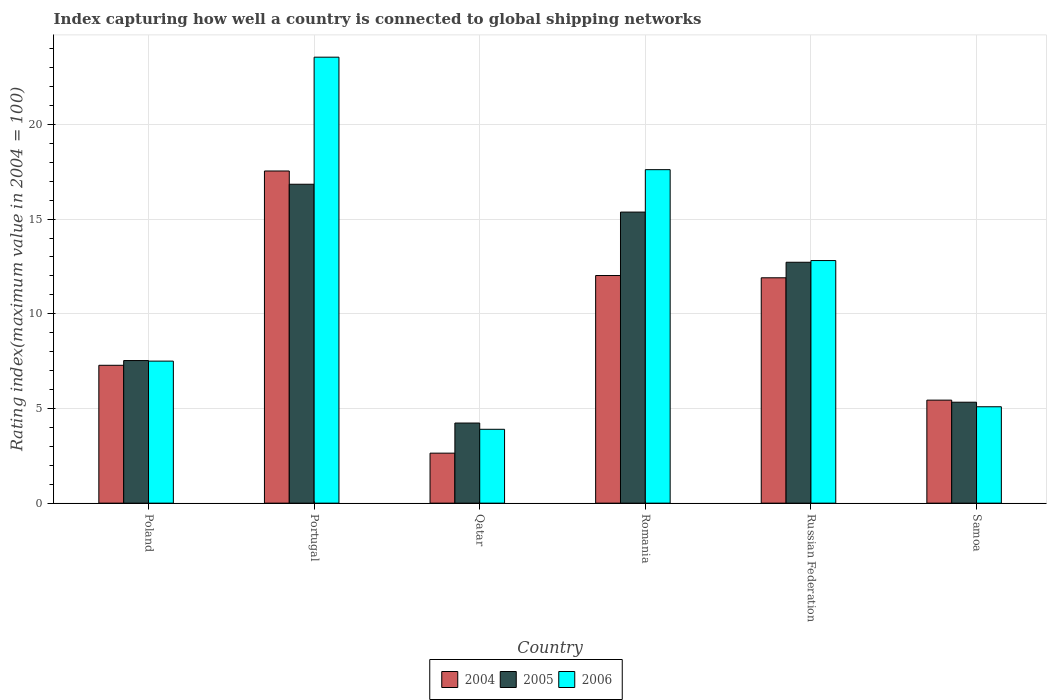How many different coloured bars are there?
Give a very brief answer. 3. Are the number of bars on each tick of the X-axis equal?
Make the answer very short. Yes. How many bars are there on the 1st tick from the left?
Offer a terse response. 3. How many bars are there on the 6th tick from the right?
Make the answer very short. 3. What is the label of the 5th group of bars from the left?
Ensure brevity in your answer.  Russian Federation. What is the rating index in 2005 in Poland?
Provide a short and direct response. 7.53. Across all countries, what is the maximum rating index in 2004?
Provide a short and direct response. 17.54. Across all countries, what is the minimum rating index in 2005?
Your answer should be compact. 4.23. In which country was the rating index in 2006 minimum?
Give a very brief answer. Qatar. What is the total rating index in 2006 in the graph?
Your answer should be compact. 70.46. What is the difference between the rating index in 2004 in Portugal and that in Russian Federation?
Make the answer very short. 5.64. What is the difference between the rating index in 2005 in Samoa and the rating index in 2004 in Qatar?
Make the answer very short. 2.69. What is the average rating index in 2006 per country?
Make the answer very short. 11.74. What is the difference between the rating index of/in 2006 and rating index of/in 2004 in Poland?
Your response must be concise. 0.22. What is the ratio of the rating index in 2005 in Qatar to that in Russian Federation?
Make the answer very short. 0.33. What is the difference between the highest and the second highest rating index in 2006?
Keep it short and to the point. 4.8. What is the difference between the highest and the lowest rating index in 2006?
Give a very brief answer. 19.65. In how many countries, is the rating index in 2004 greater than the average rating index in 2004 taken over all countries?
Make the answer very short. 3. Is the sum of the rating index in 2006 in Portugal and Qatar greater than the maximum rating index in 2004 across all countries?
Provide a short and direct response. Yes. What does the 1st bar from the left in Russian Federation represents?
Provide a succinct answer. 2004. Is it the case that in every country, the sum of the rating index in 2004 and rating index in 2005 is greater than the rating index in 2006?
Your answer should be very brief. Yes. Are all the bars in the graph horizontal?
Give a very brief answer. No. Where does the legend appear in the graph?
Give a very brief answer. Bottom center. What is the title of the graph?
Provide a short and direct response. Index capturing how well a country is connected to global shipping networks. Does "1975" appear as one of the legend labels in the graph?
Ensure brevity in your answer.  No. What is the label or title of the X-axis?
Give a very brief answer. Country. What is the label or title of the Y-axis?
Provide a succinct answer. Rating index(maximum value in 2004 = 100). What is the Rating index(maximum value in 2004 = 100) of 2004 in Poland?
Your answer should be compact. 7.28. What is the Rating index(maximum value in 2004 = 100) of 2005 in Poland?
Keep it short and to the point. 7.53. What is the Rating index(maximum value in 2004 = 100) in 2006 in Poland?
Ensure brevity in your answer.  7.5. What is the Rating index(maximum value in 2004 = 100) of 2004 in Portugal?
Give a very brief answer. 17.54. What is the Rating index(maximum value in 2004 = 100) in 2005 in Portugal?
Keep it short and to the point. 16.84. What is the Rating index(maximum value in 2004 = 100) of 2006 in Portugal?
Your response must be concise. 23.55. What is the Rating index(maximum value in 2004 = 100) of 2004 in Qatar?
Offer a terse response. 2.64. What is the Rating index(maximum value in 2004 = 100) in 2005 in Qatar?
Keep it short and to the point. 4.23. What is the Rating index(maximum value in 2004 = 100) of 2006 in Qatar?
Keep it short and to the point. 3.9. What is the Rating index(maximum value in 2004 = 100) in 2004 in Romania?
Your answer should be compact. 12.02. What is the Rating index(maximum value in 2004 = 100) in 2005 in Romania?
Offer a terse response. 15.37. What is the Rating index(maximum value in 2004 = 100) in 2006 in Romania?
Give a very brief answer. 17.61. What is the Rating index(maximum value in 2004 = 100) of 2005 in Russian Federation?
Offer a terse response. 12.72. What is the Rating index(maximum value in 2004 = 100) of 2006 in Russian Federation?
Ensure brevity in your answer.  12.81. What is the Rating index(maximum value in 2004 = 100) in 2004 in Samoa?
Make the answer very short. 5.44. What is the Rating index(maximum value in 2004 = 100) in 2005 in Samoa?
Keep it short and to the point. 5.33. What is the Rating index(maximum value in 2004 = 100) in 2006 in Samoa?
Provide a succinct answer. 5.09. Across all countries, what is the maximum Rating index(maximum value in 2004 = 100) in 2004?
Ensure brevity in your answer.  17.54. Across all countries, what is the maximum Rating index(maximum value in 2004 = 100) in 2005?
Ensure brevity in your answer.  16.84. Across all countries, what is the maximum Rating index(maximum value in 2004 = 100) in 2006?
Your answer should be compact. 23.55. Across all countries, what is the minimum Rating index(maximum value in 2004 = 100) in 2004?
Give a very brief answer. 2.64. Across all countries, what is the minimum Rating index(maximum value in 2004 = 100) in 2005?
Your answer should be compact. 4.23. Across all countries, what is the minimum Rating index(maximum value in 2004 = 100) in 2006?
Your answer should be very brief. 3.9. What is the total Rating index(maximum value in 2004 = 100) in 2004 in the graph?
Offer a terse response. 56.82. What is the total Rating index(maximum value in 2004 = 100) of 2005 in the graph?
Your response must be concise. 62.02. What is the total Rating index(maximum value in 2004 = 100) of 2006 in the graph?
Ensure brevity in your answer.  70.46. What is the difference between the Rating index(maximum value in 2004 = 100) in 2004 in Poland and that in Portugal?
Offer a terse response. -10.26. What is the difference between the Rating index(maximum value in 2004 = 100) of 2005 in Poland and that in Portugal?
Your answer should be very brief. -9.31. What is the difference between the Rating index(maximum value in 2004 = 100) in 2006 in Poland and that in Portugal?
Provide a short and direct response. -16.05. What is the difference between the Rating index(maximum value in 2004 = 100) of 2004 in Poland and that in Qatar?
Keep it short and to the point. 4.64. What is the difference between the Rating index(maximum value in 2004 = 100) in 2006 in Poland and that in Qatar?
Your answer should be compact. 3.6. What is the difference between the Rating index(maximum value in 2004 = 100) in 2004 in Poland and that in Romania?
Offer a very short reply. -4.74. What is the difference between the Rating index(maximum value in 2004 = 100) of 2005 in Poland and that in Romania?
Ensure brevity in your answer.  -7.84. What is the difference between the Rating index(maximum value in 2004 = 100) of 2006 in Poland and that in Romania?
Your response must be concise. -10.11. What is the difference between the Rating index(maximum value in 2004 = 100) of 2004 in Poland and that in Russian Federation?
Make the answer very short. -4.62. What is the difference between the Rating index(maximum value in 2004 = 100) in 2005 in Poland and that in Russian Federation?
Provide a short and direct response. -5.19. What is the difference between the Rating index(maximum value in 2004 = 100) of 2006 in Poland and that in Russian Federation?
Keep it short and to the point. -5.31. What is the difference between the Rating index(maximum value in 2004 = 100) of 2004 in Poland and that in Samoa?
Your answer should be very brief. 1.84. What is the difference between the Rating index(maximum value in 2004 = 100) in 2006 in Poland and that in Samoa?
Keep it short and to the point. 2.41. What is the difference between the Rating index(maximum value in 2004 = 100) in 2004 in Portugal and that in Qatar?
Your answer should be very brief. 14.9. What is the difference between the Rating index(maximum value in 2004 = 100) of 2005 in Portugal and that in Qatar?
Ensure brevity in your answer.  12.61. What is the difference between the Rating index(maximum value in 2004 = 100) in 2006 in Portugal and that in Qatar?
Make the answer very short. 19.65. What is the difference between the Rating index(maximum value in 2004 = 100) in 2004 in Portugal and that in Romania?
Provide a short and direct response. 5.52. What is the difference between the Rating index(maximum value in 2004 = 100) in 2005 in Portugal and that in Romania?
Your answer should be compact. 1.47. What is the difference between the Rating index(maximum value in 2004 = 100) of 2006 in Portugal and that in Romania?
Provide a short and direct response. 5.94. What is the difference between the Rating index(maximum value in 2004 = 100) in 2004 in Portugal and that in Russian Federation?
Keep it short and to the point. 5.64. What is the difference between the Rating index(maximum value in 2004 = 100) of 2005 in Portugal and that in Russian Federation?
Your answer should be very brief. 4.12. What is the difference between the Rating index(maximum value in 2004 = 100) in 2006 in Portugal and that in Russian Federation?
Provide a short and direct response. 10.74. What is the difference between the Rating index(maximum value in 2004 = 100) in 2004 in Portugal and that in Samoa?
Ensure brevity in your answer.  12.1. What is the difference between the Rating index(maximum value in 2004 = 100) in 2005 in Portugal and that in Samoa?
Your answer should be very brief. 11.51. What is the difference between the Rating index(maximum value in 2004 = 100) in 2006 in Portugal and that in Samoa?
Give a very brief answer. 18.46. What is the difference between the Rating index(maximum value in 2004 = 100) in 2004 in Qatar and that in Romania?
Ensure brevity in your answer.  -9.38. What is the difference between the Rating index(maximum value in 2004 = 100) of 2005 in Qatar and that in Romania?
Provide a short and direct response. -11.14. What is the difference between the Rating index(maximum value in 2004 = 100) of 2006 in Qatar and that in Romania?
Ensure brevity in your answer.  -13.71. What is the difference between the Rating index(maximum value in 2004 = 100) of 2004 in Qatar and that in Russian Federation?
Provide a succinct answer. -9.26. What is the difference between the Rating index(maximum value in 2004 = 100) in 2005 in Qatar and that in Russian Federation?
Provide a short and direct response. -8.49. What is the difference between the Rating index(maximum value in 2004 = 100) of 2006 in Qatar and that in Russian Federation?
Your answer should be very brief. -8.91. What is the difference between the Rating index(maximum value in 2004 = 100) in 2004 in Qatar and that in Samoa?
Make the answer very short. -2.8. What is the difference between the Rating index(maximum value in 2004 = 100) of 2005 in Qatar and that in Samoa?
Keep it short and to the point. -1.1. What is the difference between the Rating index(maximum value in 2004 = 100) in 2006 in Qatar and that in Samoa?
Provide a short and direct response. -1.19. What is the difference between the Rating index(maximum value in 2004 = 100) of 2004 in Romania and that in Russian Federation?
Offer a terse response. 0.12. What is the difference between the Rating index(maximum value in 2004 = 100) of 2005 in Romania and that in Russian Federation?
Provide a succinct answer. 2.65. What is the difference between the Rating index(maximum value in 2004 = 100) in 2004 in Romania and that in Samoa?
Make the answer very short. 6.58. What is the difference between the Rating index(maximum value in 2004 = 100) in 2005 in Romania and that in Samoa?
Offer a very short reply. 10.04. What is the difference between the Rating index(maximum value in 2004 = 100) of 2006 in Romania and that in Samoa?
Make the answer very short. 12.52. What is the difference between the Rating index(maximum value in 2004 = 100) of 2004 in Russian Federation and that in Samoa?
Offer a terse response. 6.46. What is the difference between the Rating index(maximum value in 2004 = 100) in 2005 in Russian Federation and that in Samoa?
Offer a terse response. 7.39. What is the difference between the Rating index(maximum value in 2004 = 100) in 2006 in Russian Federation and that in Samoa?
Make the answer very short. 7.72. What is the difference between the Rating index(maximum value in 2004 = 100) in 2004 in Poland and the Rating index(maximum value in 2004 = 100) in 2005 in Portugal?
Make the answer very short. -9.56. What is the difference between the Rating index(maximum value in 2004 = 100) of 2004 in Poland and the Rating index(maximum value in 2004 = 100) of 2006 in Portugal?
Your response must be concise. -16.27. What is the difference between the Rating index(maximum value in 2004 = 100) of 2005 in Poland and the Rating index(maximum value in 2004 = 100) of 2006 in Portugal?
Your response must be concise. -16.02. What is the difference between the Rating index(maximum value in 2004 = 100) in 2004 in Poland and the Rating index(maximum value in 2004 = 100) in 2005 in Qatar?
Make the answer very short. 3.05. What is the difference between the Rating index(maximum value in 2004 = 100) of 2004 in Poland and the Rating index(maximum value in 2004 = 100) of 2006 in Qatar?
Your answer should be compact. 3.38. What is the difference between the Rating index(maximum value in 2004 = 100) in 2005 in Poland and the Rating index(maximum value in 2004 = 100) in 2006 in Qatar?
Your response must be concise. 3.63. What is the difference between the Rating index(maximum value in 2004 = 100) of 2004 in Poland and the Rating index(maximum value in 2004 = 100) of 2005 in Romania?
Offer a terse response. -8.09. What is the difference between the Rating index(maximum value in 2004 = 100) of 2004 in Poland and the Rating index(maximum value in 2004 = 100) of 2006 in Romania?
Your answer should be very brief. -10.33. What is the difference between the Rating index(maximum value in 2004 = 100) in 2005 in Poland and the Rating index(maximum value in 2004 = 100) in 2006 in Romania?
Your response must be concise. -10.08. What is the difference between the Rating index(maximum value in 2004 = 100) of 2004 in Poland and the Rating index(maximum value in 2004 = 100) of 2005 in Russian Federation?
Your answer should be very brief. -5.44. What is the difference between the Rating index(maximum value in 2004 = 100) in 2004 in Poland and the Rating index(maximum value in 2004 = 100) in 2006 in Russian Federation?
Ensure brevity in your answer.  -5.53. What is the difference between the Rating index(maximum value in 2004 = 100) in 2005 in Poland and the Rating index(maximum value in 2004 = 100) in 2006 in Russian Federation?
Offer a very short reply. -5.28. What is the difference between the Rating index(maximum value in 2004 = 100) of 2004 in Poland and the Rating index(maximum value in 2004 = 100) of 2005 in Samoa?
Give a very brief answer. 1.95. What is the difference between the Rating index(maximum value in 2004 = 100) in 2004 in Poland and the Rating index(maximum value in 2004 = 100) in 2006 in Samoa?
Ensure brevity in your answer.  2.19. What is the difference between the Rating index(maximum value in 2004 = 100) of 2005 in Poland and the Rating index(maximum value in 2004 = 100) of 2006 in Samoa?
Your response must be concise. 2.44. What is the difference between the Rating index(maximum value in 2004 = 100) in 2004 in Portugal and the Rating index(maximum value in 2004 = 100) in 2005 in Qatar?
Provide a succinct answer. 13.31. What is the difference between the Rating index(maximum value in 2004 = 100) of 2004 in Portugal and the Rating index(maximum value in 2004 = 100) of 2006 in Qatar?
Your answer should be very brief. 13.64. What is the difference between the Rating index(maximum value in 2004 = 100) in 2005 in Portugal and the Rating index(maximum value in 2004 = 100) in 2006 in Qatar?
Provide a succinct answer. 12.94. What is the difference between the Rating index(maximum value in 2004 = 100) in 2004 in Portugal and the Rating index(maximum value in 2004 = 100) in 2005 in Romania?
Ensure brevity in your answer.  2.17. What is the difference between the Rating index(maximum value in 2004 = 100) of 2004 in Portugal and the Rating index(maximum value in 2004 = 100) of 2006 in Romania?
Your answer should be compact. -0.07. What is the difference between the Rating index(maximum value in 2004 = 100) of 2005 in Portugal and the Rating index(maximum value in 2004 = 100) of 2006 in Romania?
Your response must be concise. -0.77. What is the difference between the Rating index(maximum value in 2004 = 100) of 2004 in Portugal and the Rating index(maximum value in 2004 = 100) of 2005 in Russian Federation?
Ensure brevity in your answer.  4.82. What is the difference between the Rating index(maximum value in 2004 = 100) in 2004 in Portugal and the Rating index(maximum value in 2004 = 100) in 2006 in Russian Federation?
Ensure brevity in your answer.  4.73. What is the difference between the Rating index(maximum value in 2004 = 100) in 2005 in Portugal and the Rating index(maximum value in 2004 = 100) in 2006 in Russian Federation?
Offer a terse response. 4.03. What is the difference between the Rating index(maximum value in 2004 = 100) in 2004 in Portugal and the Rating index(maximum value in 2004 = 100) in 2005 in Samoa?
Give a very brief answer. 12.21. What is the difference between the Rating index(maximum value in 2004 = 100) of 2004 in Portugal and the Rating index(maximum value in 2004 = 100) of 2006 in Samoa?
Your answer should be very brief. 12.45. What is the difference between the Rating index(maximum value in 2004 = 100) of 2005 in Portugal and the Rating index(maximum value in 2004 = 100) of 2006 in Samoa?
Provide a succinct answer. 11.75. What is the difference between the Rating index(maximum value in 2004 = 100) of 2004 in Qatar and the Rating index(maximum value in 2004 = 100) of 2005 in Romania?
Ensure brevity in your answer.  -12.73. What is the difference between the Rating index(maximum value in 2004 = 100) of 2004 in Qatar and the Rating index(maximum value in 2004 = 100) of 2006 in Romania?
Make the answer very short. -14.97. What is the difference between the Rating index(maximum value in 2004 = 100) of 2005 in Qatar and the Rating index(maximum value in 2004 = 100) of 2006 in Romania?
Ensure brevity in your answer.  -13.38. What is the difference between the Rating index(maximum value in 2004 = 100) of 2004 in Qatar and the Rating index(maximum value in 2004 = 100) of 2005 in Russian Federation?
Your answer should be very brief. -10.08. What is the difference between the Rating index(maximum value in 2004 = 100) in 2004 in Qatar and the Rating index(maximum value in 2004 = 100) in 2006 in Russian Federation?
Ensure brevity in your answer.  -10.17. What is the difference between the Rating index(maximum value in 2004 = 100) in 2005 in Qatar and the Rating index(maximum value in 2004 = 100) in 2006 in Russian Federation?
Offer a terse response. -8.58. What is the difference between the Rating index(maximum value in 2004 = 100) of 2004 in Qatar and the Rating index(maximum value in 2004 = 100) of 2005 in Samoa?
Keep it short and to the point. -2.69. What is the difference between the Rating index(maximum value in 2004 = 100) of 2004 in Qatar and the Rating index(maximum value in 2004 = 100) of 2006 in Samoa?
Offer a very short reply. -2.45. What is the difference between the Rating index(maximum value in 2004 = 100) in 2005 in Qatar and the Rating index(maximum value in 2004 = 100) in 2006 in Samoa?
Your answer should be very brief. -0.86. What is the difference between the Rating index(maximum value in 2004 = 100) in 2004 in Romania and the Rating index(maximum value in 2004 = 100) in 2005 in Russian Federation?
Your response must be concise. -0.7. What is the difference between the Rating index(maximum value in 2004 = 100) of 2004 in Romania and the Rating index(maximum value in 2004 = 100) of 2006 in Russian Federation?
Ensure brevity in your answer.  -0.79. What is the difference between the Rating index(maximum value in 2004 = 100) in 2005 in Romania and the Rating index(maximum value in 2004 = 100) in 2006 in Russian Federation?
Your answer should be compact. 2.56. What is the difference between the Rating index(maximum value in 2004 = 100) of 2004 in Romania and the Rating index(maximum value in 2004 = 100) of 2005 in Samoa?
Keep it short and to the point. 6.69. What is the difference between the Rating index(maximum value in 2004 = 100) in 2004 in Romania and the Rating index(maximum value in 2004 = 100) in 2006 in Samoa?
Provide a short and direct response. 6.93. What is the difference between the Rating index(maximum value in 2004 = 100) in 2005 in Romania and the Rating index(maximum value in 2004 = 100) in 2006 in Samoa?
Provide a short and direct response. 10.28. What is the difference between the Rating index(maximum value in 2004 = 100) of 2004 in Russian Federation and the Rating index(maximum value in 2004 = 100) of 2005 in Samoa?
Give a very brief answer. 6.57. What is the difference between the Rating index(maximum value in 2004 = 100) in 2004 in Russian Federation and the Rating index(maximum value in 2004 = 100) in 2006 in Samoa?
Offer a very short reply. 6.81. What is the difference between the Rating index(maximum value in 2004 = 100) of 2005 in Russian Federation and the Rating index(maximum value in 2004 = 100) of 2006 in Samoa?
Your answer should be compact. 7.63. What is the average Rating index(maximum value in 2004 = 100) in 2004 per country?
Provide a short and direct response. 9.47. What is the average Rating index(maximum value in 2004 = 100) in 2005 per country?
Offer a terse response. 10.34. What is the average Rating index(maximum value in 2004 = 100) in 2006 per country?
Offer a very short reply. 11.74. What is the difference between the Rating index(maximum value in 2004 = 100) of 2004 and Rating index(maximum value in 2004 = 100) of 2006 in Poland?
Offer a terse response. -0.22. What is the difference between the Rating index(maximum value in 2004 = 100) of 2005 and Rating index(maximum value in 2004 = 100) of 2006 in Poland?
Provide a succinct answer. 0.03. What is the difference between the Rating index(maximum value in 2004 = 100) in 2004 and Rating index(maximum value in 2004 = 100) in 2006 in Portugal?
Provide a short and direct response. -6.01. What is the difference between the Rating index(maximum value in 2004 = 100) of 2005 and Rating index(maximum value in 2004 = 100) of 2006 in Portugal?
Your answer should be compact. -6.71. What is the difference between the Rating index(maximum value in 2004 = 100) in 2004 and Rating index(maximum value in 2004 = 100) in 2005 in Qatar?
Your answer should be compact. -1.59. What is the difference between the Rating index(maximum value in 2004 = 100) in 2004 and Rating index(maximum value in 2004 = 100) in 2006 in Qatar?
Make the answer very short. -1.26. What is the difference between the Rating index(maximum value in 2004 = 100) of 2005 and Rating index(maximum value in 2004 = 100) of 2006 in Qatar?
Keep it short and to the point. 0.33. What is the difference between the Rating index(maximum value in 2004 = 100) in 2004 and Rating index(maximum value in 2004 = 100) in 2005 in Romania?
Offer a terse response. -3.35. What is the difference between the Rating index(maximum value in 2004 = 100) of 2004 and Rating index(maximum value in 2004 = 100) of 2006 in Romania?
Provide a succinct answer. -5.59. What is the difference between the Rating index(maximum value in 2004 = 100) in 2005 and Rating index(maximum value in 2004 = 100) in 2006 in Romania?
Provide a succinct answer. -2.24. What is the difference between the Rating index(maximum value in 2004 = 100) in 2004 and Rating index(maximum value in 2004 = 100) in 2005 in Russian Federation?
Offer a terse response. -0.82. What is the difference between the Rating index(maximum value in 2004 = 100) of 2004 and Rating index(maximum value in 2004 = 100) of 2006 in Russian Federation?
Provide a succinct answer. -0.91. What is the difference between the Rating index(maximum value in 2004 = 100) of 2005 and Rating index(maximum value in 2004 = 100) of 2006 in Russian Federation?
Offer a very short reply. -0.09. What is the difference between the Rating index(maximum value in 2004 = 100) of 2004 and Rating index(maximum value in 2004 = 100) of 2005 in Samoa?
Offer a terse response. 0.11. What is the difference between the Rating index(maximum value in 2004 = 100) of 2004 and Rating index(maximum value in 2004 = 100) of 2006 in Samoa?
Provide a succinct answer. 0.35. What is the difference between the Rating index(maximum value in 2004 = 100) of 2005 and Rating index(maximum value in 2004 = 100) of 2006 in Samoa?
Your response must be concise. 0.24. What is the ratio of the Rating index(maximum value in 2004 = 100) of 2004 in Poland to that in Portugal?
Provide a short and direct response. 0.42. What is the ratio of the Rating index(maximum value in 2004 = 100) in 2005 in Poland to that in Portugal?
Offer a very short reply. 0.45. What is the ratio of the Rating index(maximum value in 2004 = 100) of 2006 in Poland to that in Portugal?
Provide a short and direct response. 0.32. What is the ratio of the Rating index(maximum value in 2004 = 100) in 2004 in Poland to that in Qatar?
Your answer should be compact. 2.76. What is the ratio of the Rating index(maximum value in 2004 = 100) of 2005 in Poland to that in Qatar?
Offer a very short reply. 1.78. What is the ratio of the Rating index(maximum value in 2004 = 100) in 2006 in Poland to that in Qatar?
Provide a short and direct response. 1.92. What is the ratio of the Rating index(maximum value in 2004 = 100) of 2004 in Poland to that in Romania?
Your answer should be very brief. 0.61. What is the ratio of the Rating index(maximum value in 2004 = 100) of 2005 in Poland to that in Romania?
Offer a terse response. 0.49. What is the ratio of the Rating index(maximum value in 2004 = 100) in 2006 in Poland to that in Romania?
Offer a terse response. 0.43. What is the ratio of the Rating index(maximum value in 2004 = 100) in 2004 in Poland to that in Russian Federation?
Keep it short and to the point. 0.61. What is the ratio of the Rating index(maximum value in 2004 = 100) in 2005 in Poland to that in Russian Federation?
Provide a short and direct response. 0.59. What is the ratio of the Rating index(maximum value in 2004 = 100) of 2006 in Poland to that in Russian Federation?
Ensure brevity in your answer.  0.59. What is the ratio of the Rating index(maximum value in 2004 = 100) in 2004 in Poland to that in Samoa?
Keep it short and to the point. 1.34. What is the ratio of the Rating index(maximum value in 2004 = 100) in 2005 in Poland to that in Samoa?
Provide a short and direct response. 1.41. What is the ratio of the Rating index(maximum value in 2004 = 100) of 2006 in Poland to that in Samoa?
Provide a succinct answer. 1.47. What is the ratio of the Rating index(maximum value in 2004 = 100) of 2004 in Portugal to that in Qatar?
Ensure brevity in your answer.  6.64. What is the ratio of the Rating index(maximum value in 2004 = 100) in 2005 in Portugal to that in Qatar?
Offer a very short reply. 3.98. What is the ratio of the Rating index(maximum value in 2004 = 100) in 2006 in Portugal to that in Qatar?
Ensure brevity in your answer.  6.04. What is the ratio of the Rating index(maximum value in 2004 = 100) of 2004 in Portugal to that in Romania?
Give a very brief answer. 1.46. What is the ratio of the Rating index(maximum value in 2004 = 100) of 2005 in Portugal to that in Romania?
Your answer should be compact. 1.1. What is the ratio of the Rating index(maximum value in 2004 = 100) of 2006 in Portugal to that in Romania?
Your response must be concise. 1.34. What is the ratio of the Rating index(maximum value in 2004 = 100) of 2004 in Portugal to that in Russian Federation?
Provide a short and direct response. 1.47. What is the ratio of the Rating index(maximum value in 2004 = 100) of 2005 in Portugal to that in Russian Federation?
Make the answer very short. 1.32. What is the ratio of the Rating index(maximum value in 2004 = 100) of 2006 in Portugal to that in Russian Federation?
Your answer should be compact. 1.84. What is the ratio of the Rating index(maximum value in 2004 = 100) of 2004 in Portugal to that in Samoa?
Make the answer very short. 3.22. What is the ratio of the Rating index(maximum value in 2004 = 100) in 2005 in Portugal to that in Samoa?
Provide a short and direct response. 3.16. What is the ratio of the Rating index(maximum value in 2004 = 100) of 2006 in Portugal to that in Samoa?
Your response must be concise. 4.63. What is the ratio of the Rating index(maximum value in 2004 = 100) in 2004 in Qatar to that in Romania?
Offer a terse response. 0.22. What is the ratio of the Rating index(maximum value in 2004 = 100) of 2005 in Qatar to that in Romania?
Your response must be concise. 0.28. What is the ratio of the Rating index(maximum value in 2004 = 100) in 2006 in Qatar to that in Romania?
Your answer should be very brief. 0.22. What is the ratio of the Rating index(maximum value in 2004 = 100) in 2004 in Qatar to that in Russian Federation?
Your response must be concise. 0.22. What is the ratio of the Rating index(maximum value in 2004 = 100) of 2005 in Qatar to that in Russian Federation?
Ensure brevity in your answer.  0.33. What is the ratio of the Rating index(maximum value in 2004 = 100) of 2006 in Qatar to that in Russian Federation?
Offer a terse response. 0.3. What is the ratio of the Rating index(maximum value in 2004 = 100) in 2004 in Qatar to that in Samoa?
Your answer should be very brief. 0.49. What is the ratio of the Rating index(maximum value in 2004 = 100) in 2005 in Qatar to that in Samoa?
Provide a succinct answer. 0.79. What is the ratio of the Rating index(maximum value in 2004 = 100) of 2006 in Qatar to that in Samoa?
Offer a very short reply. 0.77. What is the ratio of the Rating index(maximum value in 2004 = 100) in 2004 in Romania to that in Russian Federation?
Your answer should be compact. 1.01. What is the ratio of the Rating index(maximum value in 2004 = 100) of 2005 in Romania to that in Russian Federation?
Your answer should be very brief. 1.21. What is the ratio of the Rating index(maximum value in 2004 = 100) of 2006 in Romania to that in Russian Federation?
Keep it short and to the point. 1.37. What is the ratio of the Rating index(maximum value in 2004 = 100) in 2004 in Romania to that in Samoa?
Your answer should be compact. 2.21. What is the ratio of the Rating index(maximum value in 2004 = 100) of 2005 in Romania to that in Samoa?
Provide a short and direct response. 2.88. What is the ratio of the Rating index(maximum value in 2004 = 100) of 2006 in Romania to that in Samoa?
Ensure brevity in your answer.  3.46. What is the ratio of the Rating index(maximum value in 2004 = 100) of 2004 in Russian Federation to that in Samoa?
Your answer should be compact. 2.19. What is the ratio of the Rating index(maximum value in 2004 = 100) in 2005 in Russian Federation to that in Samoa?
Offer a terse response. 2.39. What is the ratio of the Rating index(maximum value in 2004 = 100) of 2006 in Russian Federation to that in Samoa?
Make the answer very short. 2.52. What is the difference between the highest and the second highest Rating index(maximum value in 2004 = 100) in 2004?
Ensure brevity in your answer.  5.52. What is the difference between the highest and the second highest Rating index(maximum value in 2004 = 100) of 2005?
Give a very brief answer. 1.47. What is the difference between the highest and the second highest Rating index(maximum value in 2004 = 100) of 2006?
Give a very brief answer. 5.94. What is the difference between the highest and the lowest Rating index(maximum value in 2004 = 100) of 2005?
Your response must be concise. 12.61. What is the difference between the highest and the lowest Rating index(maximum value in 2004 = 100) in 2006?
Provide a succinct answer. 19.65. 